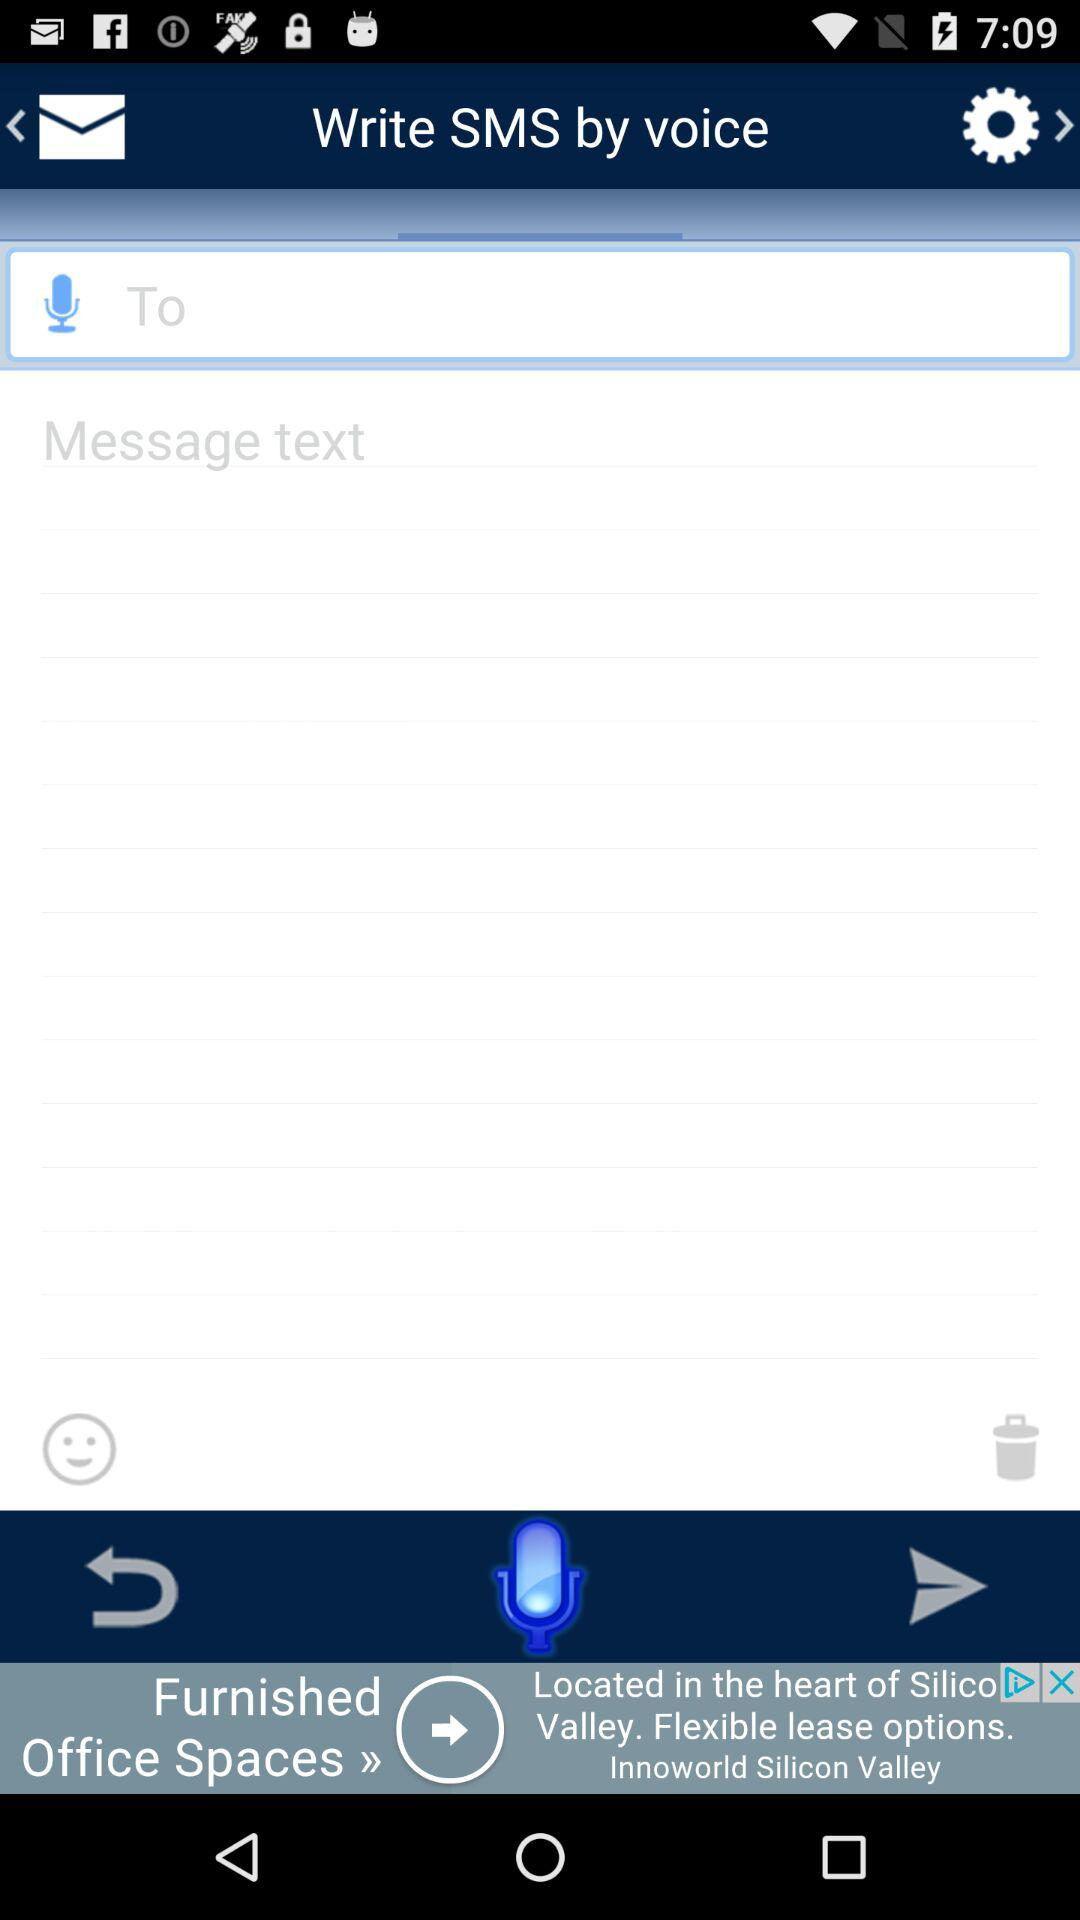How many input fields are present in the UI?
Answer the question using a single word or phrase. 2 